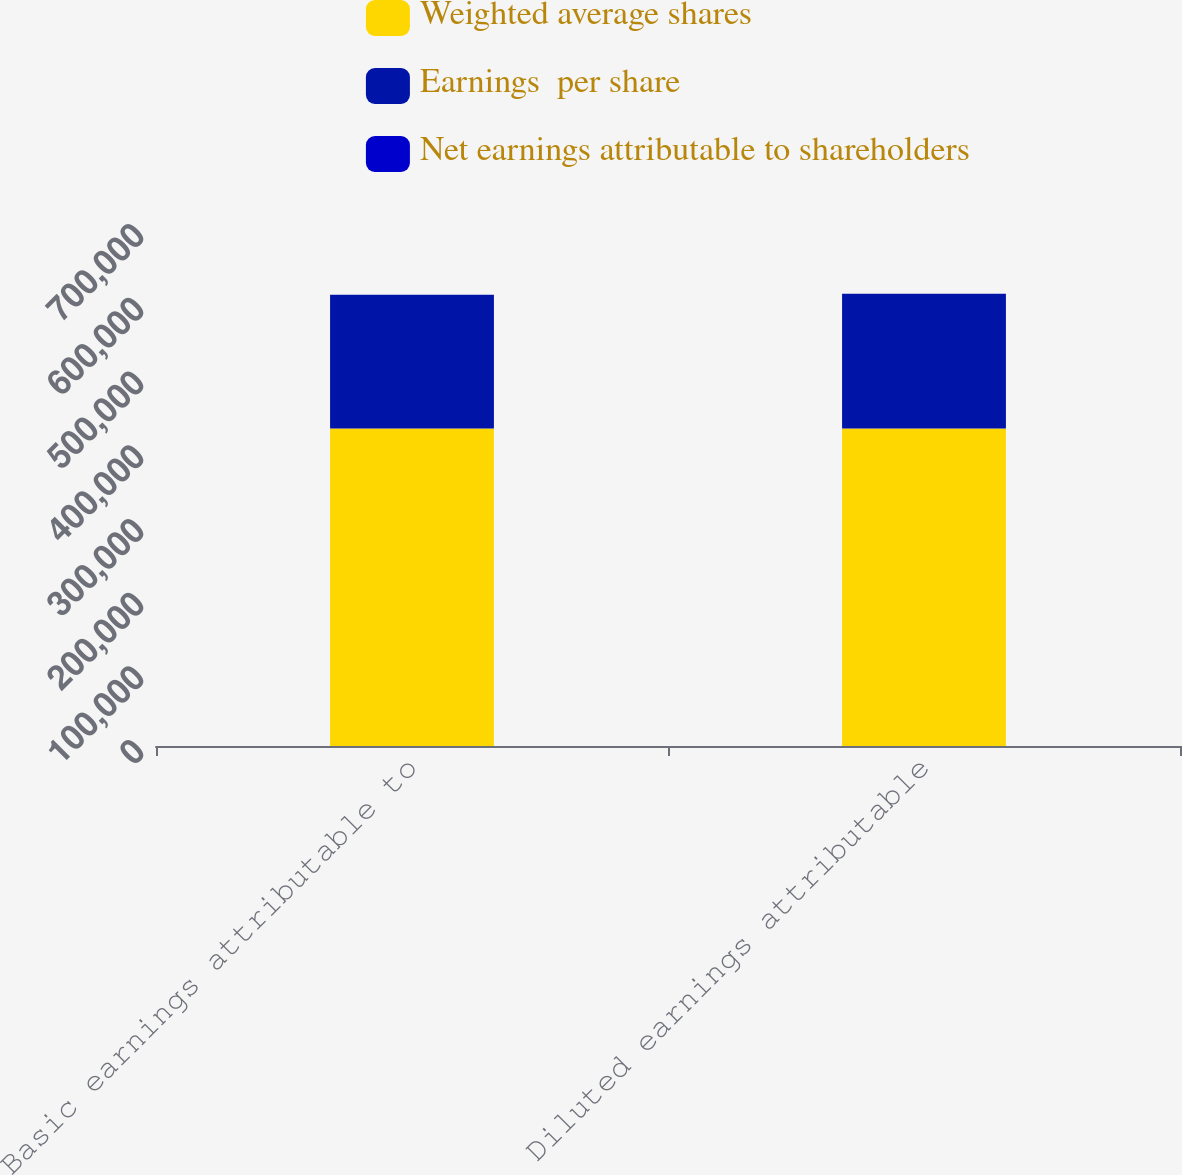<chart> <loc_0><loc_0><loc_500><loc_500><stacked_bar_chart><ecel><fcel>Basic earnings attributable to<fcel>Diluted earnings attributable<nl><fcel>Weighted average shares<fcel>430807<fcel>430807<nl><fcel>Earnings  per share<fcel>181282<fcel>182704<nl><fcel>Net earnings attributable to shareholders<fcel>2.38<fcel>2.36<nl></chart> 